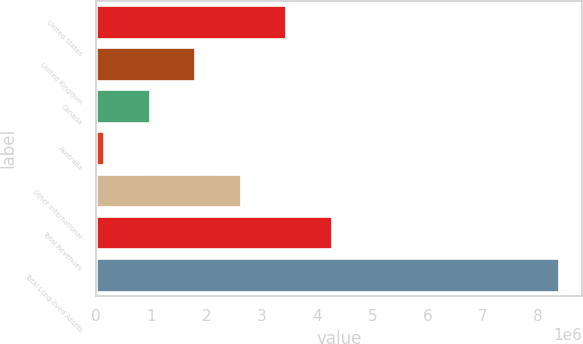Convert chart. <chart><loc_0><loc_0><loc_500><loc_500><bar_chart><fcel>United States<fcel>United Kingdom<fcel>Canada<fcel>Australia<fcel>Other International<fcel>Total Revenues<fcel>Total Long-lived Assets<nl><fcel>3.43878e+06<fcel>1.79348e+06<fcel>970827<fcel>148175<fcel>2.61613e+06<fcel>4.26143e+06<fcel>8.37469e+06<nl></chart> 